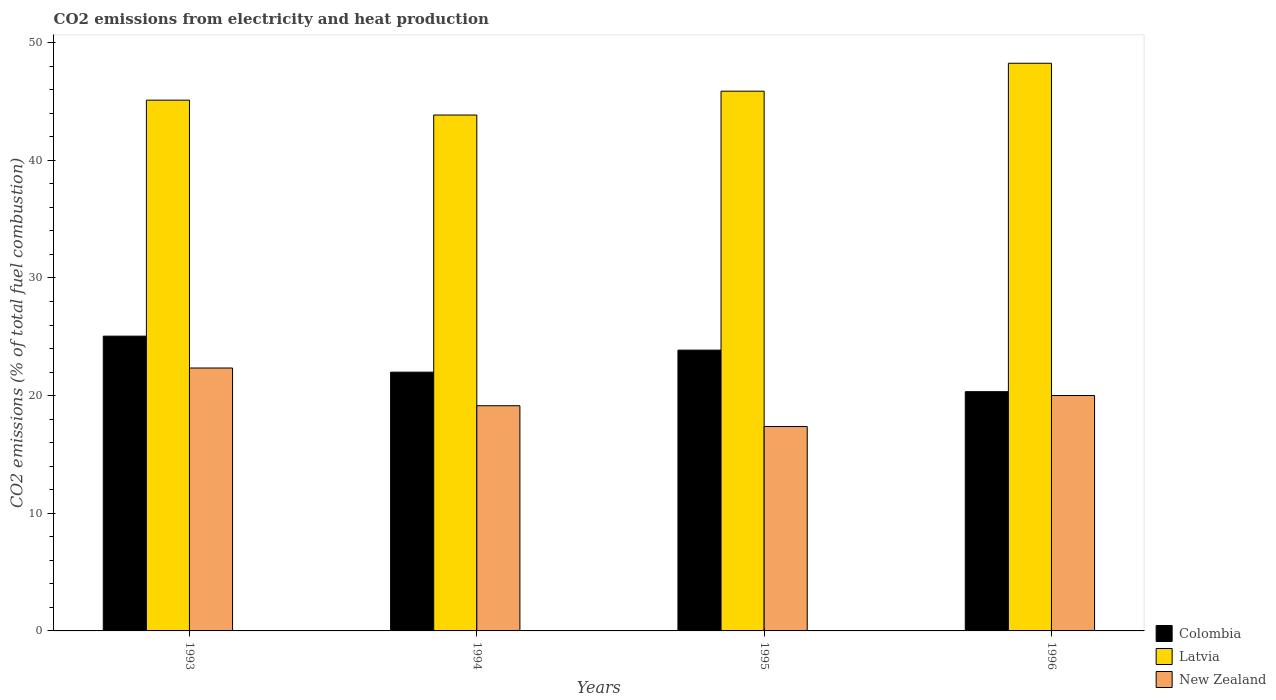How many groups of bars are there?
Offer a terse response. 4. Are the number of bars per tick equal to the number of legend labels?
Keep it short and to the point. Yes. Are the number of bars on each tick of the X-axis equal?
Your answer should be compact. Yes. How many bars are there on the 2nd tick from the left?
Your response must be concise. 3. In how many cases, is the number of bars for a given year not equal to the number of legend labels?
Make the answer very short. 0. What is the amount of CO2 emitted in Latvia in 1996?
Your answer should be very brief. 48.25. Across all years, what is the maximum amount of CO2 emitted in New Zealand?
Your answer should be compact. 22.35. Across all years, what is the minimum amount of CO2 emitted in Latvia?
Provide a succinct answer. 43.85. In which year was the amount of CO2 emitted in Colombia minimum?
Offer a very short reply. 1996. What is the total amount of CO2 emitted in Colombia in the graph?
Offer a very short reply. 91.25. What is the difference between the amount of CO2 emitted in Colombia in 1993 and that in 1994?
Provide a succinct answer. 3.06. What is the difference between the amount of CO2 emitted in Latvia in 1993 and the amount of CO2 emitted in New Zealand in 1996?
Offer a very short reply. 25.1. What is the average amount of CO2 emitted in New Zealand per year?
Provide a short and direct response. 19.72. In the year 1993, what is the difference between the amount of CO2 emitted in Colombia and amount of CO2 emitted in New Zealand?
Ensure brevity in your answer.  2.71. What is the ratio of the amount of CO2 emitted in Latvia in 1993 to that in 1994?
Keep it short and to the point. 1.03. What is the difference between the highest and the second highest amount of CO2 emitted in New Zealand?
Give a very brief answer. 2.34. What is the difference between the highest and the lowest amount of CO2 emitted in New Zealand?
Offer a very short reply. 4.97. In how many years, is the amount of CO2 emitted in New Zealand greater than the average amount of CO2 emitted in New Zealand taken over all years?
Your answer should be very brief. 2. What does the 1st bar from the left in 1993 represents?
Give a very brief answer. Colombia. What does the 3rd bar from the right in 1996 represents?
Provide a succinct answer. Colombia. How many years are there in the graph?
Provide a succinct answer. 4. What is the difference between two consecutive major ticks on the Y-axis?
Make the answer very short. 10. Are the values on the major ticks of Y-axis written in scientific E-notation?
Your answer should be compact. No. Does the graph contain grids?
Ensure brevity in your answer.  No. Where does the legend appear in the graph?
Provide a short and direct response. Bottom right. How many legend labels are there?
Offer a very short reply. 3. How are the legend labels stacked?
Offer a very short reply. Vertical. What is the title of the graph?
Keep it short and to the point. CO2 emissions from electricity and heat production. What is the label or title of the X-axis?
Ensure brevity in your answer.  Years. What is the label or title of the Y-axis?
Make the answer very short. CO2 emissions (% of total fuel combustion). What is the CO2 emissions (% of total fuel combustion) in Colombia in 1993?
Provide a short and direct response. 25.05. What is the CO2 emissions (% of total fuel combustion) in Latvia in 1993?
Provide a succinct answer. 45.11. What is the CO2 emissions (% of total fuel combustion) in New Zealand in 1993?
Offer a terse response. 22.35. What is the CO2 emissions (% of total fuel combustion) in Colombia in 1994?
Ensure brevity in your answer.  21.99. What is the CO2 emissions (% of total fuel combustion) of Latvia in 1994?
Ensure brevity in your answer.  43.85. What is the CO2 emissions (% of total fuel combustion) of New Zealand in 1994?
Your answer should be very brief. 19.14. What is the CO2 emissions (% of total fuel combustion) of Colombia in 1995?
Provide a short and direct response. 23.87. What is the CO2 emissions (% of total fuel combustion) of Latvia in 1995?
Give a very brief answer. 45.88. What is the CO2 emissions (% of total fuel combustion) in New Zealand in 1995?
Provide a short and direct response. 17.37. What is the CO2 emissions (% of total fuel combustion) in Colombia in 1996?
Offer a very short reply. 20.33. What is the CO2 emissions (% of total fuel combustion) of Latvia in 1996?
Offer a very short reply. 48.25. What is the CO2 emissions (% of total fuel combustion) in New Zealand in 1996?
Provide a succinct answer. 20.01. Across all years, what is the maximum CO2 emissions (% of total fuel combustion) of Colombia?
Offer a terse response. 25.05. Across all years, what is the maximum CO2 emissions (% of total fuel combustion) in Latvia?
Your response must be concise. 48.25. Across all years, what is the maximum CO2 emissions (% of total fuel combustion) of New Zealand?
Make the answer very short. 22.35. Across all years, what is the minimum CO2 emissions (% of total fuel combustion) in Colombia?
Provide a short and direct response. 20.33. Across all years, what is the minimum CO2 emissions (% of total fuel combustion) in Latvia?
Your answer should be very brief. 43.85. Across all years, what is the minimum CO2 emissions (% of total fuel combustion) in New Zealand?
Give a very brief answer. 17.37. What is the total CO2 emissions (% of total fuel combustion) of Colombia in the graph?
Offer a terse response. 91.25. What is the total CO2 emissions (% of total fuel combustion) in Latvia in the graph?
Your answer should be compact. 183.09. What is the total CO2 emissions (% of total fuel combustion) in New Zealand in the graph?
Offer a terse response. 78.87. What is the difference between the CO2 emissions (% of total fuel combustion) in Colombia in 1993 and that in 1994?
Ensure brevity in your answer.  3.06. What is the difference between the CO2 emissions (% of total fuel combustion) of Latvia in 1993 and that in 1994?
Give a very brief answer. 1.26. What is the difference between the CO2 emissions (% of total fuel combustion) of New Zealand in 1993 and that in 1994?
Provide a short and direct response. 3.21. What is the difference between the CO2 emissions (% of total fuel combustion) of Colombia in 1993 and that in 1995?
Provide a short and direct response. 1.19. What is the difference between the CO2 emissions (% of total fuel combustion) in Latvia in 1993 and that in 1995?
Ensure brevity in your answer.  -0.76. What is the difference between the CO2 emissions (% of total fuel combustion) of New Zealand in 1993 and that in 1995?
Keep it short and to the point. 4.97. What is the difference between the CO2 emissions (% of total fuel combustion) in Colombia in 1993 and that in 1996?
Your answer should be very brief. 4.72. What is the difference between the CO2 emissions (% of total fuel combustion) of Latvia in 1993 and that in 1996?
Your answer should be very brief. -3.14. What is the difference between the CO2 emissions (% of total fuel combustion) of New Zealand in 1993 and that in 1996?
Keep it short and to the point. 2.34. What is the difference between the CO2 emissions (% of total fuel combustion) of Colombia in 1994 and that in 1995?
Ensure brevity in your answer.  -1.87. What is the difference between the CO2 emissions (% of total fuel combustion) in Latvia in 1994 and that in 1995?
Your answer should be very brief. -2.03. What is the difference between the CO2 emissions (% of total fuel combustion) of New Zealand in 1994 and that in 1995?
Provide a succinct answer. 1.77. What is the difference between the CO2 emissions (% of total fuel combustion) in Colombia in 1994 and that in 1996?
Make the answer very short. 1.66. What is the difference between the CO2 emissions (% of total fuel combustion) of Latvia in 1994 and that in 1996?
Your answer should be very brief. -4.4. What is the difference between the CO2 emissions (% of total fuel combustion) of New Zealand in 1994 and that in 1996?
Your response must be concise. -0.87. What is the difference between the CO2 emissions (% of total fuel combustion) of Colombia in 1995 and that in 1996?
Ensure brevity in your answer.  3.53. What is the difference between the CO2 emissions (% of total fuel combustion) in Latvia in 1995 and that in 1996?
Keep it short and to the point. -2.37. What is the difference between the CO2 emissions (% of total fuel combustion) of New Zealand in 1995 and that in 1996?
Give a very brief answer. -2.64. What is the difference between the CO2 emissions (% of total fuel combustion) in Colombia in 1993 and the CO2 emissions (% of total fuel combustion) in Latvia in 1994?
Keep it short and to the point. -18.8. What is the difference between the CO2 emissions (% of total fuel combustion) in Colombia in 1993 and the CO2 emissions (% of total fuel combustion) in New Zealand in 1994?
Keep it short and to the point. 5.91. What is the difference between the CO2 emissions (% of total fuel combustion) in Latvia in 1993 and the CO2 emissions (% of total fuel combustion) in New Zealand in 1994?
Provide a short and direct response. 25.97. What is the difference between the CO2 emissions (% of total fuel combustion) of Colombia in 1993 and the CO2 emissions (% of total fuel combustion) of Latvia in 1995?
Your response must be concise. -20.82. What is the difference between the CO2 emissions (% of total fuel combustion) in Colombia in 1993 and the CO2 emissions (% of total fuel combustion) in New Zealand in 1995?
Your answer should be compact. 7.68. What is the difference between the CO2 emissions (% of total fuel combustion) in Latvia in 1993 and the CO2 emissions (% of total fuel combustion) in New Zealand in 1995?
Provide a succinct answer. 27.74. What is the difference between the CO2 emissions (% of total fuel combustion) of Colombia in 1993 and the CO2 emissions (% of total fuel combustion) of Latvia in 1996?
Provide a succinct answer. -23.19. What is the difference between the CO2 emissions (% of total fuel combustion) in Colombia in 1993 and the CO2 emissions (% of total fuel combustion) in New Zealand in 1996?
Offer a very short reply. 5.05. What is the difference between the CO2 emissions (% of total fuel combustion) of Latvia in 1993 and the CO2 emissions (% of total fuel combustion) of New Zealand in 1996?
Give a very brief answer. 25.1. What is the difference between the CO2 emissions (% of total fuel combustion) in Colombia in 1994 and the CO2 emissions (% of total fuel combustion) in Latvia in 1995?
Offer a very short reply. -23.88. What is the difference between the CO2 emissions (% of total fuel combustion) of Colombia in 1994 and the CO2 emissions (% of total fuel combustion) of New Zealand in 1995?
Keep it short and to the point. 4.62. What is the difference between the CO2 emissions (% of total fuel combustion) in Latvia in 1994 and the CO2 emissions (% of total fuel combustion) in New Zealand in 1995?
Provide a succinct answer. 26.48. What is the difference between the CO2 emissions (% of total fuel combustion) in Colombia in 1994 and the CO2 emissions (% of total fuel combustion) in Latvia in 1996?
Your response must be concise. -26.26. What is the difference between the CO2 emissions (% of total fuel combustion) in Colombia in 1994 and the CO2 emissions (% of total fuel combustion) in New Zealand in 1996?
Your answer should be compact. 1.99. What is the difference between the CO2 emissions (% of total fuel combustion) in Latvia in 1994 and the CO2 emissions (% of total fuel combustion) in New Zealand in 1996?
Ensure brevity in your answer.  23.84. What is the difference between the CO2 emissions (% of total fuel combustion) in Colombia in 1995 and the CO2 emissions (% of total fuel combustion) in Latvia in 1996?
Keep it short and to the point. -24.38. What is the difference between the CO2 emissions (% of total fuel combustion) of Colombia in 1995 and the CO2 emissions (% of total fuel combustion) of New Zealand in 1996?
Offer a terse response. 3.86. What is the difference between the CO2 emissions (% of total fuel combustion) in Latvia in 1995 and the CO2 emissions (% of total fuel combustion) in New Zealand in 1996?
Keep it short and to the point. 25.87. What is the average CO2 emissions (% of total fuel combustion) of Colombia per year?
Offer a terse response. 22.81. What is the average CO2 emissions (% of total fuel combustion) in Latvia per year?
Offer a very short reply. 45.77. What is the average CO2 emissions (% of total fuel combustion) in New Zealand per year?
Give a very brief answer. 19.72. In the year 1993, what is the difference between the CO2 emissions (% of total fuel combustion) in Colombia and CO2 emissions (% of total fuel combustion) in Latvia?
Give a very brief answer. -20.06. In the year 1993, what is the difference between the CO2 emissions (% of total fuel combustion) of Colombia and CO2 emissions (% of total fuel combustion) of New Zealand?
Your answer should be very brief. 2.71. In the year 1993, what is the difference between the CO2 emissions (% of total fuel combustion) of Latvia and CO2 emissions (% of total fuel combustion) of New Zealand?
Your answer should be very brief. 22.76. In the year 1994, what is the difference between the CO2 emissions (% of total fuel combustion) of Colombia and CO2 emissions (% of total fuel combustion) of Latvia?
Offer a terse response. -21.86. In the year 1994, what is the difference between the CO2 emissions (% of total fuel combustion) in Colombia and CO2 emissions (% of total fuel combustion) in New Zealand?
Ensure brevity in your answer.  2.85. In the year 1994, what is the difference between the CO2 emissions (% of total fuel combustion) of Latvia and CO2 emissions (% of total fuel combustion) of New Zealand?
Ensure brevity in your answer.  24.71. In the year 1995, what is the difference between the CO2 emissions (% of total fuel combustion) of Colombia and CO2 emissions (% of total fuel combustion) of Latvia?
Ensure brevity in your answer.  -22.01. In the year 1995, what is the difference between the CO2 emissions (% of total fuel combustion) of Colombia and CO2 emissions (% of total fuel combustion) of New Zealand?
Offer a terse response. 6.49. In the year 1995, what is the difference between the CO2 emissions (% of total fuel combustion) in Latvia and CO2 emissions (% of total fuel combustion) in New Zealand?
Offer a terse response. 28.5. In the year 1996, what is the difference between the CO2 emissions (% of total fuel combustion) of Colombia and CO2 emissions (% of total fuel combustion) of Latvia?
Your answer should be very brief. -27.91. In the year 1996, what is the difference between the CO2 emissions (% of total fuel combustion) of Colombia and CO2 emissions (% of total fuel combustion) of New Zealand?
Offer a terse response. 0.33. In the year 1996, what is the difference between the CO2 emissions (% of total fuel combustion) of Latvia and CO2 emissions (% of total fuel combustion) of New Zealand?
Make the answer very short. 28.24. What is the ratio of the CO2 emissions (% of total fuel combustion) in Colombia in 1993 to that in 1994?
Your answer should be very brief. 1.14. What is the ratio of the CO2 emissions (% of total fuel combustion) of Latvia in 1993 to that in 1994?
Your answer should be compact. 1.03. What is the ratio of the CO2 emissions (% of total fuel combustion) of New Zealand in 1993 to that in 1994?
Provide a succinct answer. 1.17. What is the ratio of the CO2 emissions (% of total fuel combustion) of Colombia in 1993 to that in 1995?
Your answer should be very brief. 1.05. What is the ratio of the CO2 emissions (% of total fuel combustion) of Latvia in 1993 to that in 1995?
Offer a very short reply. 0.98. What is the ratio of the CO2 emissions (% of total fuel combustion) of New Zealand in 1993 to that in 1995?
Give a very brief answer. 1.29. What is the ratio of the CO2 emissions (% of total fuel combustion) of Colombia in 1993 to that in 1996?
Provide a short and direct response. 1.23. What is the ratio of the CO2 emissions (% of total fuel combustion) in Latvia in 1993 to that in 1996?
Provide a succinct answer. 0.94. What is the ratio of the CO2 emissions (% of total fuel combustion) of New Zealand in 1993 to that in 1996?
Your answer should be very brief. 1.12. What is the ratio of the CO2 emissions (% of total fuel combustion) in Colombia in 1994 to that in 1995?
Offer a terse response. 0.92. What is the ratio of the CO2 emissions (% of total fuel combustion) of Latvia in 1994 to that in 1995?
Your answer should be very brief. 0.96. What is the ratio of the CO2 emissions (% of total fuel combustion) in New Zealand in 1994 to that in 1995?
Ensure brevity in your answer.  1.1. What is the ratio of the CO2 emissions (% of total fuel combustion) in Colombia in 1994 to that in 1996?
Make the answer very short. 1.08. What is the ratio of the CO2 emissions (% of total fuel combustion) in Latvia in 1994 to that in 1996?
Give a very brief answer. 0.91. What is the ratio of the CO2 emissions (% of total fuel combustion) in New Zealand in 1994 to that in 1996?
Your answer should be very brief. 0.96. What is the ratio of the CO2 emissions (% of total fuel combustion) of Colombia in 1995 to that in 1996?
Provide a succinct answer. 1.17. What is the ratio of the CO2 emissions (% of total fuel combustion) in Latvia in 1995 to that in 1996?
Your response must be concise. 0.95. What is the ratio of the CO2 emissions (% of total fuel combustion) in New Zealand in 1995 to that in 1996?
Offer a very short reply. 0.87. What is the difference between the highest and the second highest CO2 emissions (% of total fuel combustion) in Colombia?
Offer a very short reply. 1.19. What is the difference between the highest and the second highest CO2 emissions (% of total fuel combustion) of Latvia?
Your response must be concise. 2.37. What is the difference between the highest and the second highest CO2 emissions (% of total fuel combustion) in New Zealand?
Your answer should be very brief. 2.34. What is the difference between the highest and the lowest CO2 emissions (% of total fuel combustion) of Colombia?
Provide a succinct answer. 4.72. What is the difference between the highest and the lowest CO2 emissions (% of total fuel combustion) of Latvia?
Give a very brief answer. 4.4. What is the difference between the highest and the lowest CO2 emissions (% of total fuel combustion) in New Zealand?
Your answer should be compact. 4.97. 